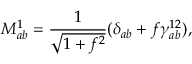<formula> <loc_0><loc_0><loc_500><loc_500>M _ { a b } ^ { 1 } = \frac { 1 } { \sqrt { 1 + f ^ { 2 } } } ( \delta _ { a b } + f \gamma _ { a b } ^ { 1 2 } ) ,</formula> 